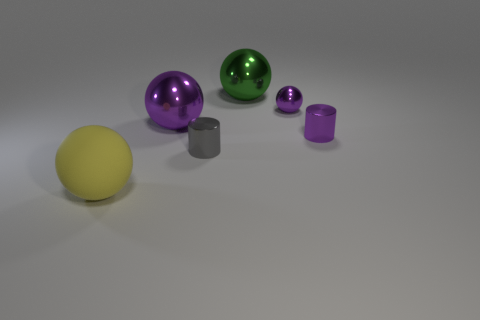How many cylinders are right of the small cylinder that is on the left side of the large green sphere? There is 1 cylinder positioned to the right of the small cylinder, which itself is located on the left side of the large green sphere. 